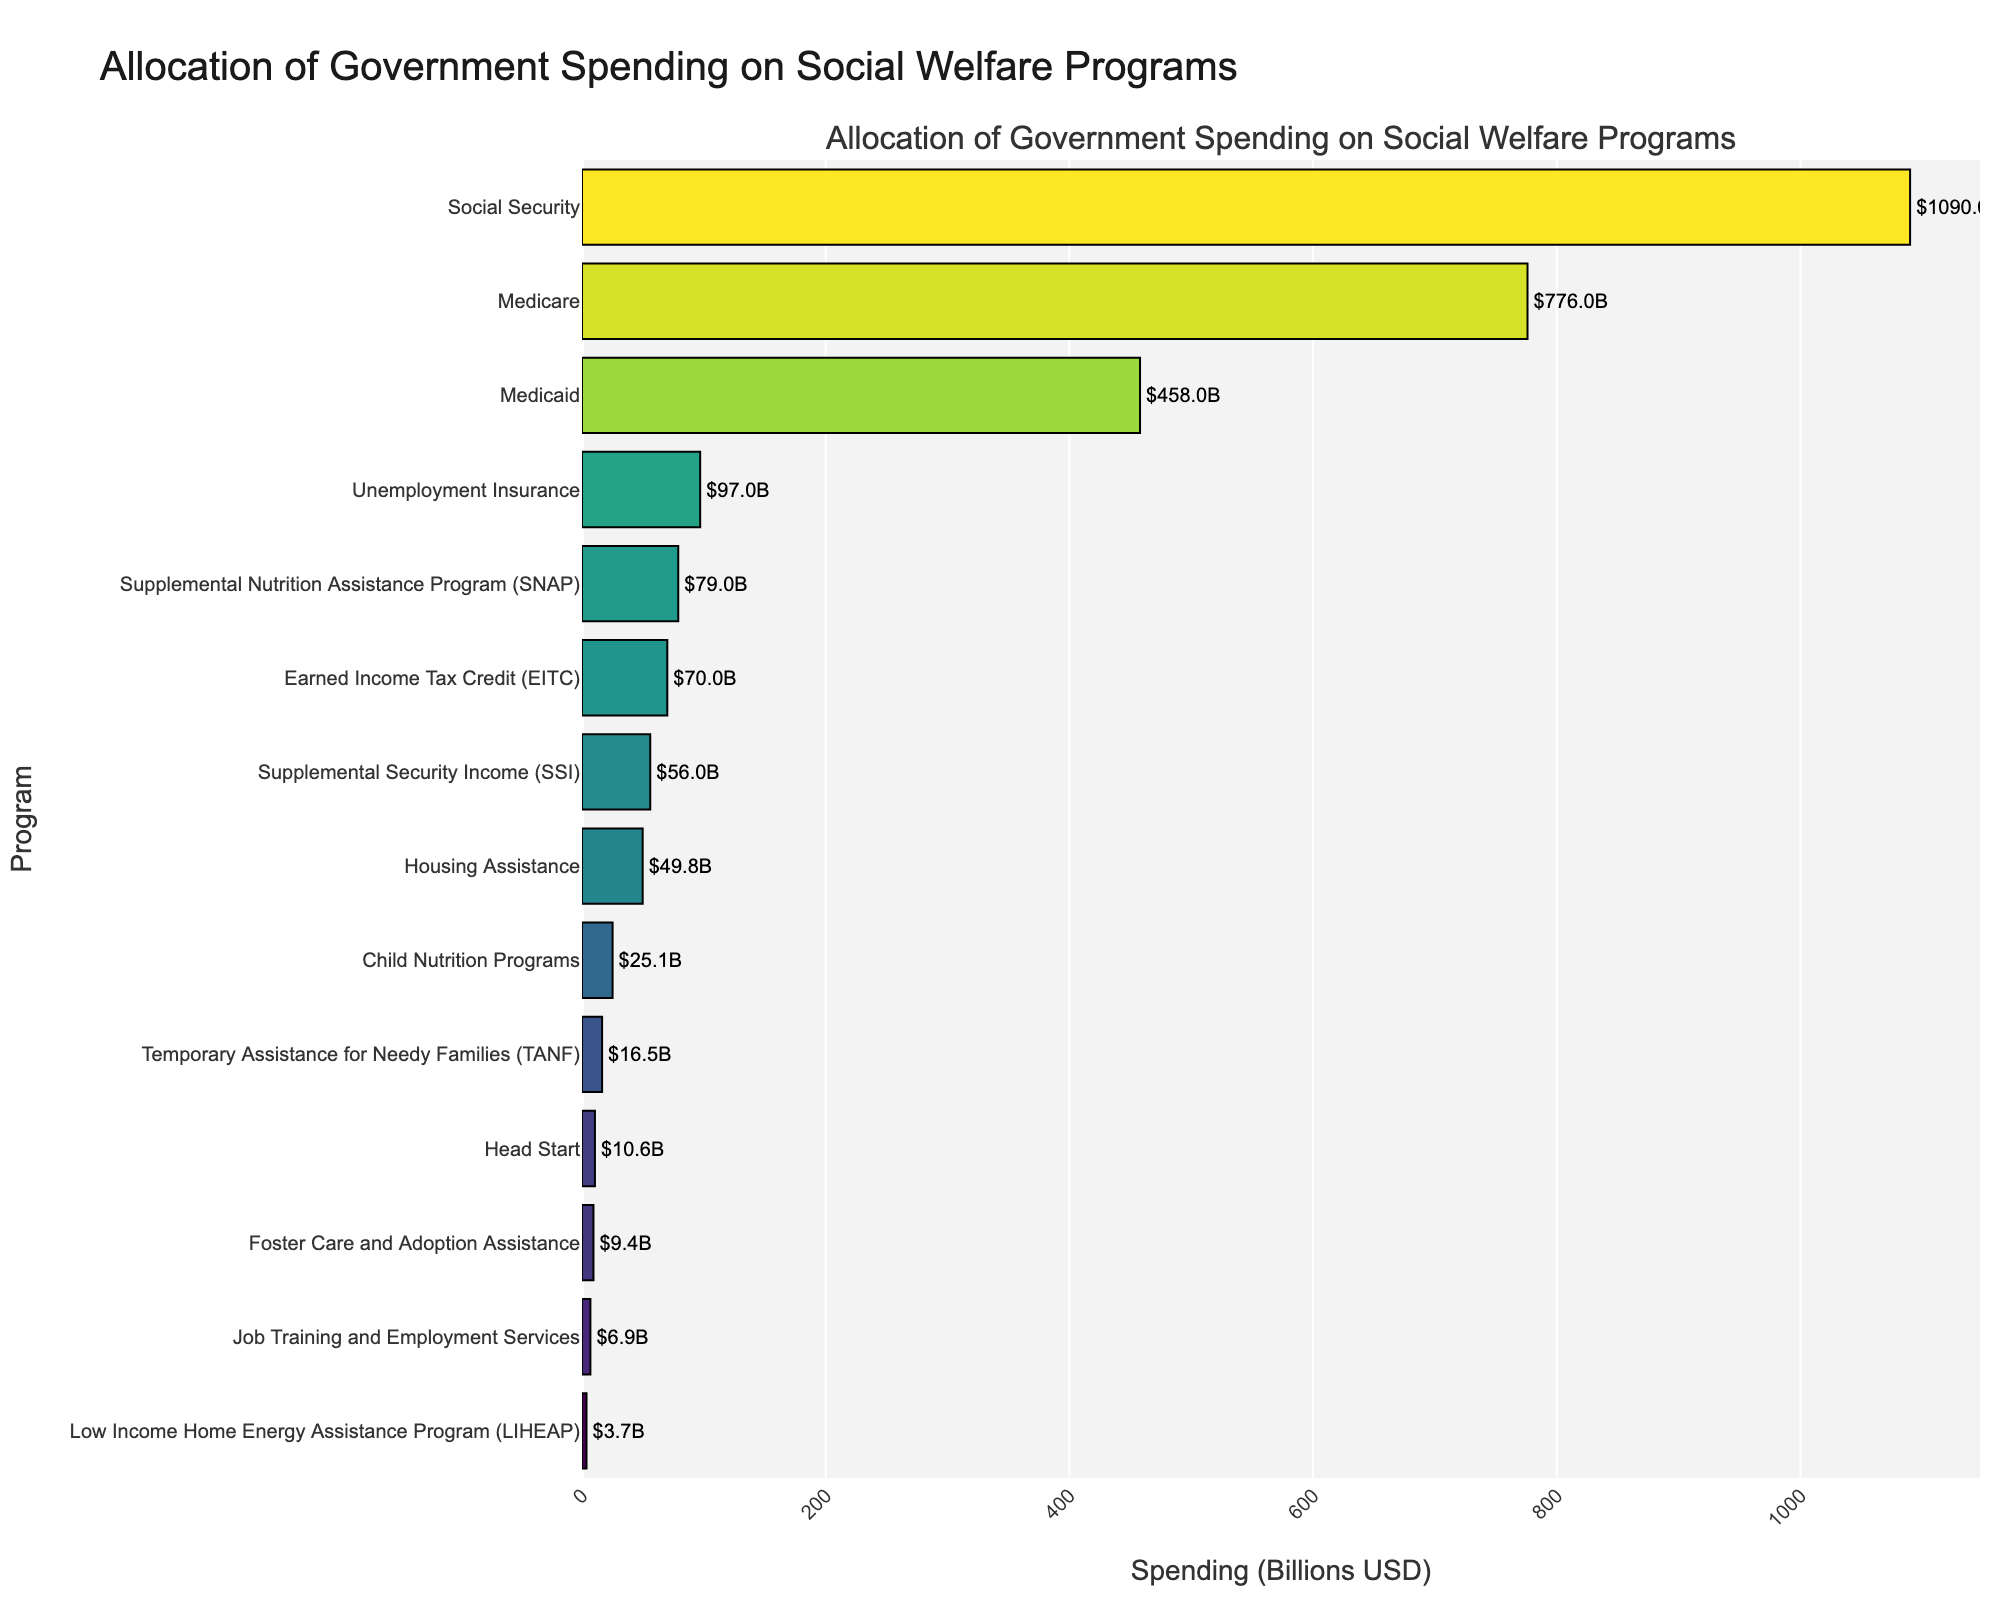Which program receives the highest allocation of government spending? Identify the program with the longest bar, indicating the highest spending.
Answer: Social Security Which program has the lowest spending? Look at the shortest bar to identify the program with the lowest spending.
Answer: Low Income Home Energy Assistance Program (LIHEAP) How much more is allocated to Medicare compared to Medicaid? Find and compare the bars for Medicare and Medicaid. Subtract Medicaid's spending ($458B) from Medicare's spending ($776B): 776 - 458 = 318.
Answer: $318B What is the total spending for programs with less than $100B allocated? Add the spending amounts of all programs with less than $100B: Unemployment Insurance ($97B), SNAP ($79B), EITC ($70B), SSI ($56B), TANF ($16.5B), Child Nutrition Programs ($25.1B), Housing Assistance ($49.8B), LIHEAP ($3.7B), Head Start ($10.6B), Job Training and Employment Services ($6.9B), Foster Care and Adoption Assistance ($9.4B). Total = 97 + 79 + 70 + 56 + 16.5 + 25.1 + 49.8 + 3.7 + 10.6 + 6.9 + 9.4 = 424
Answer: $424B What's the ratio of spending between Social Security and Head Start? Find the spending amounts for Social Security and Head Start and compute the ratio by dividing Social Security's spending ($1090B) by Head Start's spending ($10.6B): 1090 / 10.6 ≈ 102.8.
Answer: 102.8 Which program’s bar uses the deepest color on the colorscale, and what does this signify? Identify the bar with the deepest color, which represents the highest logarithm of the spending value. Deep colors indicate higher relative spending. The deepest color corresponds to Social Security, which also has the highest overall spending.
Answer: Social Security, highest spending Are there more programs with spending above or below $100B? Count the programs with spending below $100B and those above $100B, then compare: Above $100B (3 programs: Social Security, Medicare, Medicaid), Below $100B (11 programs).
Answer: Below How much more is allocated to Social Security compared to the total spending of Medicaid and Medicare combined? Add the spending for Medicaid and Medicare ($776B + $458B = $1234B), then subtract this total from Social Security’s spending ($1090B): 1090 - 1234 = -144.
Answer: $-144B 